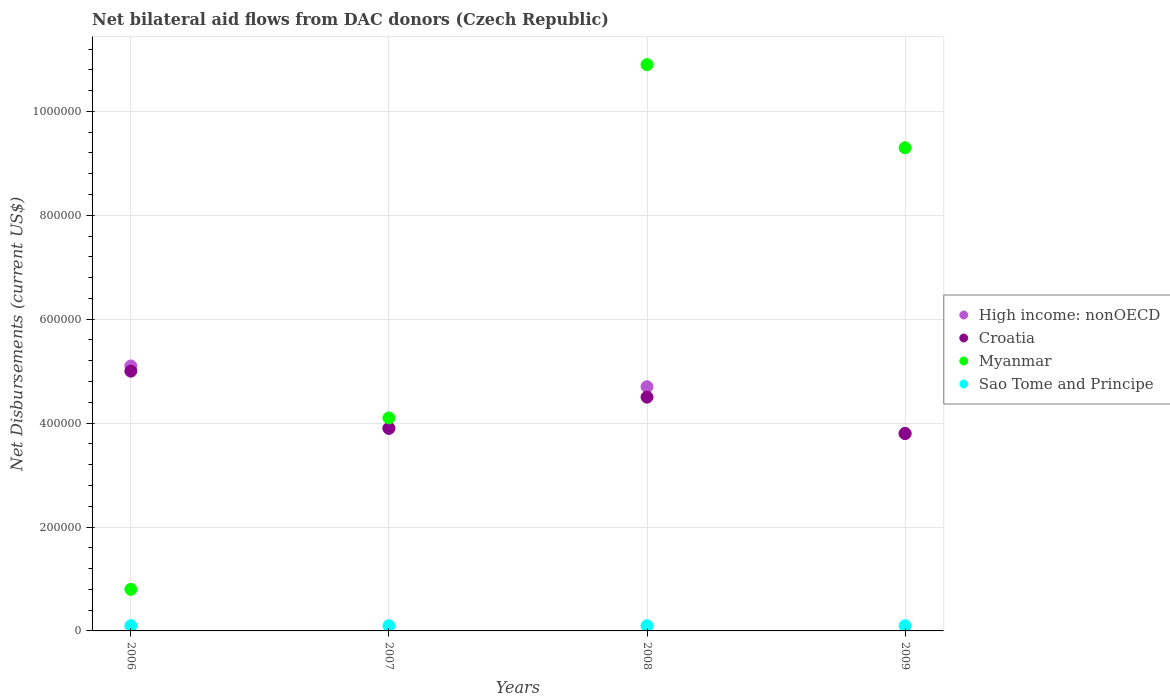Is the number of dotlines equal to the number of legend labels?
Ensure brevity in your answer.  Yes. Across all years, what is the maximum net bilateral aid flows in Myanmar?
Give a very brief answer. 1.09e+06. Across all years, what is the minimum net bilateral aid flows in High income: nonOECD?
Keep it short and to the point. 3.80e+05. What is the total net bilateral aid flows in Myanmar in the graph?
Ensure brevity in your answer.  2.51e+06. What is the difference between the net bilateral aid flows in Sao Tome and Principe in 2007 and that in 2009?
Your answer should be very brief. 0. What is the average net bilateral aid flows in Croatia per year?
Give a very brief answer. 4.30e+05. In the year 2007, what is the difference between the net bilateral aid flows in High income: nonOECD and net bilateral aid flows in Croatia?
Your answer should be compact. 0. In how many years, is the net bilateral aid flows in Croatia greater than 840000 US$?
Make the answer very short. 0. What is the ratio of the net bilateral aid flows in Myanmar in 2006 to that in 2007?
Make the answer very short. 0.2. Is the difference between the net bilateral aid flows in High income: nonOECD in 2006 and 2008 greater than the difference between the net bilateral aid flows in Croatia in 2006 and 2008?
Keep it short and to the point. No. What is the difference between the highest and the second highest net bilateral aid flows in Sao Tome and Principe?
Your response must be concise. 0. What is the difference between the highest and the lowest net bilateral aid flows in Myanmar?
Provide a short and direct response. 1.01e+06. Is the sum of the net bilateral aid flows in Sao Tome and Principe in 2006 and 2007 greater than the maximum net bilateral aid flows in Croatia across all years?
Give a very brief answer. No. Is it the case that in every year, the sum of the net bilateral aid flows in Croatia and net bilateral aid flows in Sao Tome and Principe  is greater than the sum of net bilateral aid flows in Myanmar and net bilateral aid flows in High income: nonOECD?
Provide a succinct answer. No. Is the net bilateral aid flows in Myanmar strictly less than the net bilateral aid flows in Croatia over the years?
Provide a short and direct response. No. How many dotlines are there?
Ensure brevity in your answer.  4. What is the difference between two consecutive major ticks on the Y-axis?
Your response must be concise. 2.00e+05. Does the graph contain any zero values?
Your response must be concise. No. Does the graph contain grids?
Your answer should be very brief. Yes. Where does the legend appear in the graph?
Keep it short and to the point. Center right. How many legend labels are there?
Make the answer very short. 4. How are the legend labels stacked?
Give a very brief answer. Vertical. What is the title of the graph?
Your answer should be very brief. Net bilateral aid flows from DAC donors (Czech Republic). What is the label or title of the X-axis?
Make the answer very short. Years. What is the label or title of the Y-axis?
Keep it short and to the point. Net Disbursements (current US$). What is the Net Disbursements (current US$) of High income: nonOECD in 2006?
Your response must be concise. 5.10e+05. What is the Net Disbursements (current US$) in Myanmar in 2006?
Ensure brevity in your answer.  8.00e+04. What is the Net Disbursements (current US$) in Sao Tome and Principe in 2006?
Provide a short and direct response. 10000. What is the Net Disbursements (current US$) of Croatia in 2007?
Keep it short and to the point. 3.90e+05. What is the Net Disbursements (current US$) in Sao Tome and Principe in 2007?
Your answer should be very brief. 10000. What is the Net Disbursements (current US$) of Myanmar in 2008?
Give a very brief answer. 1.09e+06. What is the Net Disbursements (current US$) of Croatia in 2009?
Your answer should be compact. 3.80e+05. What is the Net Disbursements (current US$) in Myanmar in 2009?
Your answer should be compact. 9.30e+05. Across all years, what is the maximum Net Disbursements (current US$) in High income: nonOECD?
Your answer should be very brief. 5.10e+05. Across all years, what is the maximum Net Disbursements (current US$) of Myanmar?
Make the answer very short. 1.09e+06. Across all years, what is the maximum Net Disbursements (current US$) of Sao Tome and Principe?
Offer a terse response. 10000. Across all years, what is the minimum Net Disbursements (current US$) in High income: nonOECD?
Your response must be concise. 3.80e+05. Across all years, what is the minimum Net Disbursements (current US$) of Sao Tome and Principe?
Your answer should be very brief. 10000. What is the total Net Disbursements (current US$) in High income: nonOECD in the graph?
Your answer should be very brief. 1.75e+06. What is the total Net Disbursements (current US$) in Croatia in the graph?
Give a very brief answer. 1.72e+06. What is the total Net Disbursements (current US$) of Myanmar in the graph?
Your answer should be compact. 2.51e+06. What is the difference between the Net Disbursements (current US$) in High income: nonOECD in 2006 and that in 2007?
Offer a very short reply. 1.20e+05. What is the difference between the Net Disbursements (current US$) in Croatia in 2006 and that in 2007?
Give a very brief answer. 1.10e+05. What is the difference between the Net Disbursements (current US$) of Myanmar in 2006 and that in 2007?
Offer a terse response. -3.30e+05. What is the difference between the Net Disbursements (current US$) of Myanmar in 2006 and that in 2008?
Provide a short and direct response. -1.01e+06. What is the difference between the Net Disbursements (current US$) in Sao Tome and Principe in 2006 and that in 2008?
Keep it short and to the point. 0. What is the difference between the Net Disbursements (current US$) in Myanmar in 2006 and that in 2009?
Ensure brevity in your answer.  -8.50e+05. What is the difference between the Net Disbursements (current US$) in Sao Tome and Principe in 2006 and that in 2009?
Provide a succinct answer. 0. What is the difference between the Net Disbursements (current US$) in Myanmar in 2007 and that in 2008?
Offer a terse response. -6.80e+05. What is the difference between the Net Disbursements (current US$) in Sao Tome and Principe in 2007 and that in 2008?
Your response must be concise. 0. What is the difference between the Net Disbursements (current US$) of Croatia in 2007 and that in 2009?
Keep it short and to the point. 10000. What is the difference between the Net Disbursements (current US$) of Myanmar in 2007 and that in 2009?
Ensure brevity in your answer.  -5.20e+05. What is the difference between the Net Disbursements (current US$) in Sao Tome and Principe in 2007 and that in 2009?
Provide a short and direct response. 0. What is the difference between the Net Disbursements (current US$) in High income: nonOECD in 2008 and that in 2009?
Keep it short and to the point. 9.00e+04. What is the difference between the Net Disbursements (current US$) of Croatia in 2008 and that in 2009?
Make the answer very short. 7.00e+04. What is the difference between the Net Disbursements (current US$) of Myanmar in 2008 and that in 2009?
Offer a very short reply. 1.60e+05. What is the difference between the Net Disbursements (current US$) of Sao Tome and Principe in 2008 and that in 2009?
Offer a very short reply. 0. What is the difference between the Net Disbursements (current US$) of High income: nonOECD in 2006 and the Net Disbursements (current US$) of Croatia in 2007?
Make the answer very short. 1.20e+05. What is the difference between the Net Disbursements (current US$) of High income: nonOECD in 2006 and the Net Disbursements (current US$) of Myanmar in 2007?
Offer a terse response. 1.00e+05. What is the difference between the Net Disbursements (current US$) in Croatia in 2006 and the Net Disbursements (current US$) in Myanmar in 2007?
Offer a terse response. 9.00e+04. What is the difference between the Net Disbursements (current US$) of Myanmar in 2006 and the Net Disbursements (current US$) of Sao Tome and Principe in 2007?
Offer a very short reply. 7.00e+04. What is the difference between the Net Disbursements (current US$) of High income: nonOECD in 2006 and the Net Disbursements (current US$) of Myanmar in 2008?
Offer a very short reply. -5.80e+05. What is the difference between the Net Disbursements (current US$) of Croatia in 2006 and the Net Disbursements (current US$) of Myanmar in 2008?
Keep it short and to the point. -5.90e+05. What is the difference between the Net Disbursements (current US$) of High income: nonOECD in 2006 and the Net Disbursements (current US$) of Croatia in 2009?
Offer a terse response. 1.30e+05. What is the difference between the Net Disbursements (current US$) of High income: nonOECD in 2006 and the Net Disbursements (current US$) of Myanmar in 2009?
Provide a succinct answer. -4.20e+05. What is the difference between the Net Disbursements (current US$) in Croatia in 2006 and the Net Disbursements (current US$) in Myanmar in 2009?
Offer a very short reply. -4.30e+05. What is the difference between the Net Disbursements (current US$) in High income: nonOECD in 2007 and the Net Disbursements (current US$) in Myanmar in 2008?
Keep it short and to the point. -7.00e+05. What is the difference between the Net Disbursements (current US$) in High income: nonOECD in 2007 and the Net Disbursements (current US$) in Sao Tome and Principe in 2008?
Provide a short and direct response. 3.80e+05. What is the difference between the Net Disbursements (current US$) of Croatia in 2007 and the Net Disbursements (current US$) of Myanmar in 2008?
Make the answer very short. -7.00e+05. What is the difference between the Net Disbursements (current US$) of Myanmar in 2007 and the Net Disbursements (current US$) of Sao Tome and Principe in 2008?
Offer a terse response. 4.00e+05. What is the difference between the Net Disbursements (current US$) in High income: nonOECD in 2007 and the Net Disbursements (current US$) in Croatia in 2009?
Offer a very short reply. 10000. What is the difference between the Net Disbursements (current US$) of High income: nonOECD in 2007 and the Net Disbursements (current US$) of Myanmar in 2009?
Offer a very short reply. -5.40e+05. What is the difference between the Net Disbursements (current US$) of High income: nonOECD in 2007 and the Net Disbursements (current US$) of Sao Tome and Principe in 2009?
Keep it short and to the point. 3.80e+05. What is the difference between the Net Disbursements (current US$) of Croatia in 2007 and the Net Disbursements (current US$) of Myanmar in 2009?
Ensure brevity in your answer.  -5.40e+05. What is the difference between the Net Disbursements (current US$) in Croatia in 2007 and the Net Disbursements (current US$) in Sao Tome and Principe in 2009?
Your response must be concise. 3.80e+05. What is the difference between the Net Disbursements (current US$) of Myanmar in 2007 and the Net Disbursements (current US$) of Sao Tome and Principe in 2009?
Provide a short and direct response. 4.00e+05. What is the difference between the Net Disbursements (current US$) in High income: nonOECD in 2008 and the Net Disbursements (current US$) in Croatia in 2009?
Your answer should be very brief. 9.00e+04. What is the difference between the Net Disbursements (current US$) of High income: nonOECD in 2008 and the Net Disbursements (current US$) of Myanmar in 2009?
Your answer should be compact. -4.60e+05. What is the difference between the Net Disbursements (current US$) of High income: nonOECD in 2008 and the Net Disbursements (current US$) of Sao Tome and Principe in 2009?
Offer a very short reply. 4.60e+05. What is the difference between the Net Disbursements (current US$) in Croatia in 2008 and the Net Disbursements (current US$) in Myanmar in 2009?
Your response must be concise. -4.80e+05. What is the difference between the Net Disbursements (current US$) of Croatia in 2008 and the Net Disbursements (current US$) of Sao Tome and Principe in 2009?
Provide a succinct answer. 4.40e+05. What is the difference between the Net Disbursements (current US$) in Myanmar in 2008 and the Net Disbursements (current US$) in Sao Tome and Principe in 2009?
Ensure brevity in your answer.  1.08e+06. What is the average Net Disbursements (current US$) in High income: nonOECD per year?
Keep it short and to the point. 4.38e+05. What is the average Net Disbursements (current US$) of Croatia per year?
Your answer should be compact. 4.30e+05. What is the average Net Disbursements (current US$) in Myanmar per year?
Provide a succinct answer. 6.28e+05. In the year 2006, what is the difference between the Net Disbursements (current US$) in High income: nonOECD and Net Disbursements (current US$) in Croatia?
Make the answer very short. 10000. In the year 2006, what is the difference between the Net Disbursements (current US$) of Croatia and Net Disbursements (current US$) of Myanmar?
Make the answer very short. 4.20e+05. In the year 2006, what is the difference between the Net Disbursements (current US$) of Croatia and Net Disbursements (current US$) of Sao Tome and Principe?
Your answer should be compact. 4.90e+05. In the year 2006, what is the difference between the Net Disbursements (current US$) of Myanmar and Net Disbursements (current US$) of Sao Tome and Principe?
Your answer should be very brief. 7.00e+04. In the year 2007, what is the difference between the Net Disbursements (current US$) of High income: nonOECD and Net Disbursements (current US$) of Croatia?
Ensure brevity in your answer.  0. In the year 2007, what is the difference between the Net Disbursements (current US$) of High income: nonOECD and Net Disbursements (current US$) of Myanmar?
Your response must be concise. -2.00e+04. In the year 2007, what is the difference between the Net Disbursements (current US$) of Croatia and Net Disbursements (current US$) of Myanmar?
Ensure brevity in your answer.  -2.00e+04. In the year 2008, what is the difference between the Net Disbursements (current US$) of High income: nonOECD and Net Disbursements (current US$) of Myanmar?
Offer a very short reply. -6.20e+05. In the year 2008, what is the difference between the Net Disbursements (current US$) of High income: nonOECD and Net Disbursements (current US$) of Sao Tome and Principe?
Ensure brevity in your answer.  4.60e+05. In the year 2008, what is the difference between the Net Disbursements (current US$) in Croatia and Net Disbursements (current US$) in Myanmar?
Give a very brief answer. -6.40e+05. In the year 2008, what is the difference between the Net Disbursements (current US$) of Myanmar and Net Disbursements (current US$) of Sao Tome and Principe?
Provide a short and direct response. 1.08e+06. In the year 2009, what is the difference between the Net Disbursements (current US$) in High income: nonOECD and Net Disbursements (current US$) in Myanmar?
Keep it short and to the point. -5.50e+05. In the year 2009, what is the difference between the Net Disbursements (current US$) in High income: nonOECD and Net Disbursements (current US$) in Sao Tome and Principe?
Give a very brief answer. 3.70e+05. In the year 2009, what is the difference between the Net Disbursements (current US$) in Croatia and Net Disbursements (current US$) in Myanmar?
Your response must be concise. -5.50e+05. In the year 2009, what is the difference between the Net Disbursements (current US$) of Myanmar and Net Disbursements (current US$) of Sao Tome and Principe?
Offer a very short reply. 9.20e+05. What is the ratio of the Net Disbursements (current US$) of High income: nonOECD in 2006 to that in 2007?
Your response must be concise. 1.31. What is the ratio of the Net Disbursements (current US$) of Croatia in 2006 to that in 2007?
Your answer should be very brief. 1.28. What is the ratio of the Net Disbursements (current US$) of Myanmar in 2006 to that in 2007?
Offer a very short reply. 0.2. What is the ratio of the Net Disbursements (current US$) of Sao Tome and Principe in 2006 to that in 2007?
Your answer should be very brief. 1. What is the ratio of the Net Disbursements (current US$) of High income: nonOECD in 2006 to that in 2008?
Your answer should be very brief. 1.09. What is the ratio of the Net Disbursements (current US$) in Myanmar in 2006 to that in 2008?
Make the answer very short. 0.07. What is the ratio of the Net Disbursements (current US$) of Sao Tome and Principe in 2006 to that in 2008?
Make the answer very short. 1. What is the ratio of the Net Disbursements (current US$) of High income: nonOECD in 2006 to that in 2009?
Ensure brevity in your answer.  1.34. What is the ratio of the Net Disbursements (current US$) of Croatia in 2006 to that in 2009?
Your response must be concise. 1.32. What is the ratio of the Net Disbursements (current US$) in Myanmar in 2006 to that in 2009?
Your response must be concise. 0.09. What is the ratio of the Net Disbursements (current US$) in High income: nonOECD in 2007 to that in 2008?
Offer a very short reply. 0.83. What is the ratio of the Net Disbursements (current US$) of Croatia in 2007 to that in 2008?
Make the answer very short. 0.87. What is the ratio of the Net Disbursements (current US$) of Myanmar in 2007 to that in 2008?
Your answer should be very brief. 0.38. What is the ratio of the Net Disbursements (current US$) of High income: nonOECD in 2007 to that in 2009?
Offer a very short reply. 1.03. What is the ratio of the Net Disbursements (current US$) of Croatia in 2007 to that in 2009?
Provide a succinct answer. 1.03. What is the ratio of the Net Disbursements (current US$) of Myanmar in 2007 to that in 2009?
Provide a short and direct response. 0.44. What is the ratio of the Net Disbursements (current US$) in High income: nonOECD in 2008 to that in 2009?
Offer a very short reply. 1.24. What is the ratio of the Net Disbursements (current US$) of Croatia in 2008 to that in 2009?
Offer a terse response. 1.18. What is the ratio of the Net Disbursements (current US$) of Myanmar in 2008 to that in 2009?
Keep it short and to the point. 1.17. What is the ratio of the Net Disbursements (current US$) in Sao Tome and Principe in 2008 to that in 2009?
Keep it short and to the point. 1. What is the difference between the highest and the second highest Net Disbursements (current US$) of High income: nonOECD?
Your response must be concise. 4.00e+04. What is the difference between the highest and the second highest Net Disbursements (current US$) in Myanmar?
Your answer should be compact. 1.60e+05. What is the difference between the highest and the second highest Net Disbursements (current US$) of Sao Tome and Principe?
Your answer should be compact. 0. What is the difference between the highest and the lowest Net Disbursements (current US$) in High income: nonOECD?
Keep it short and to the point. 1.30e+05. What is the difference between the highest and the lowest Net Disbursements (current US$) of Myanmar?
Give a very brief answer. 1.01e+06. What is the difference between the highest and the lowest Net Disbursements (current US$) of Sao Tome and Principe?
Your answer should be compact. 0. 